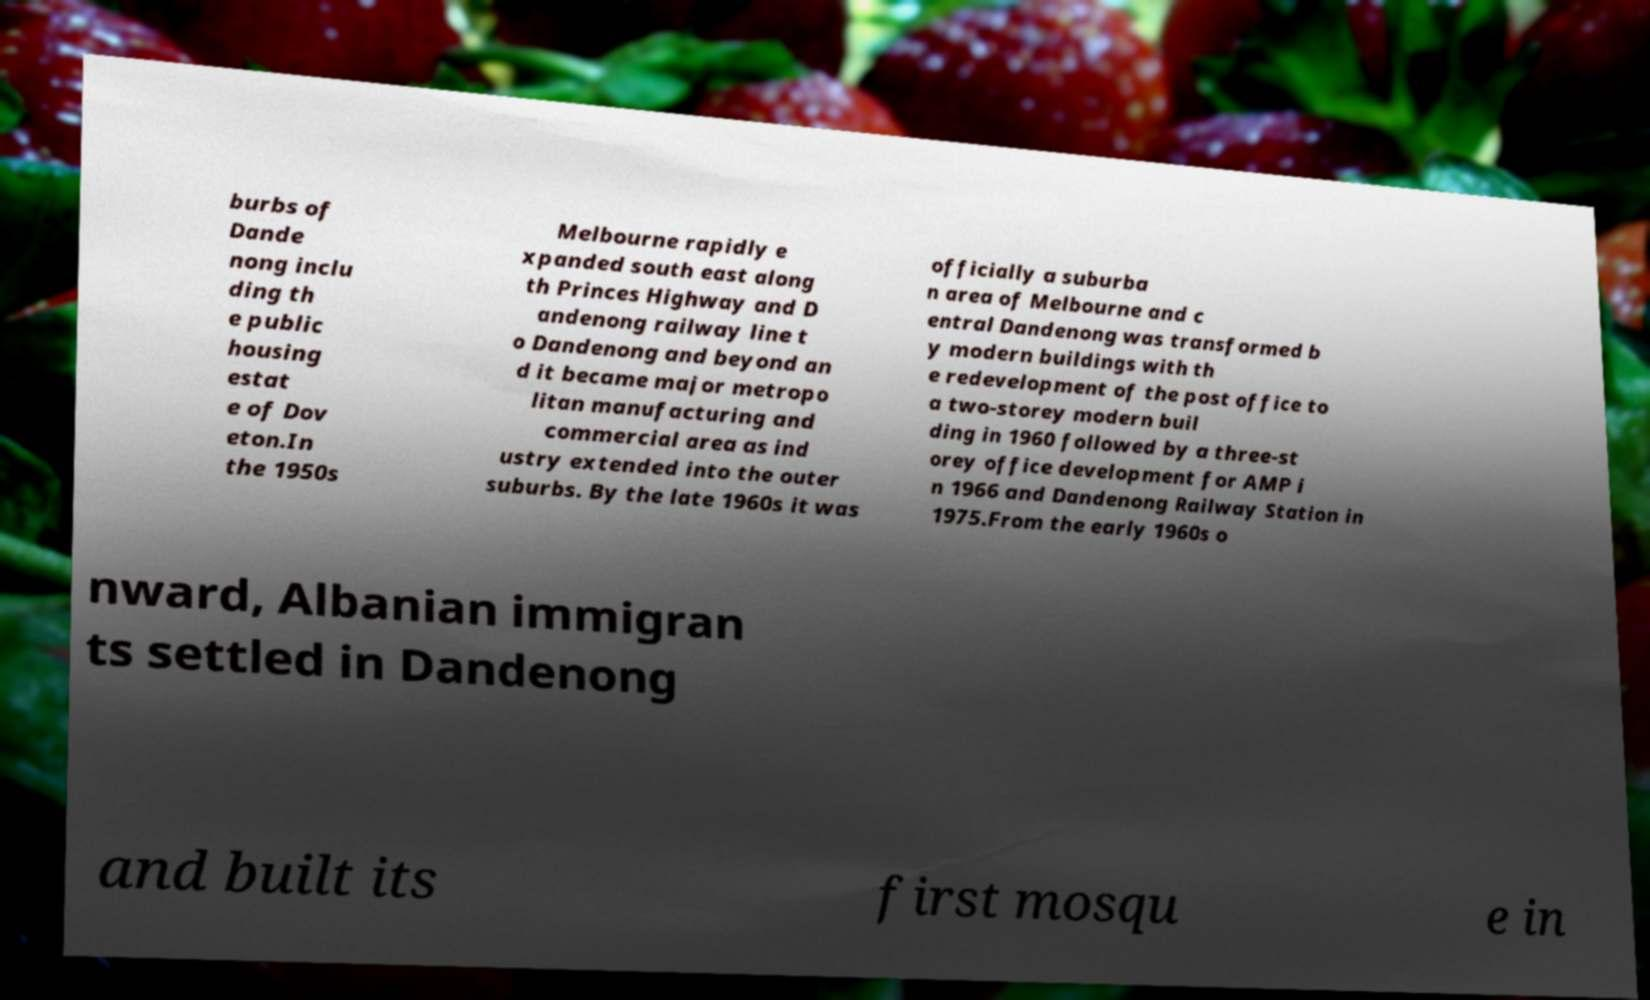For documentation purposes, I need the text within this image transcribed. Could you provide that? burbs of Dande nong inclu ding th e public housing estat e of Dov eton.In the 1950s Melbourne rapidly e xpanded south east along th Princes Highway and D andenong railway line t o Dandenong and beyond an d it became major metropo litan manufacturing and commercial area as ind ustry extended into the outer suburbs. By the late 1960s it was officially a suburba n area of Melbourne and c entral Dandenong was transformed b y modern buildings with th e redevelopment of the post office to a two-storey modern buil ding in 1960 followed by a three-st orey office development for AMP i n 1966 and Dandenong Railway Station in 1975.From the early 1960s o nward, Albanian immigran ts settled in Dandenong and built its first mosqu e in 